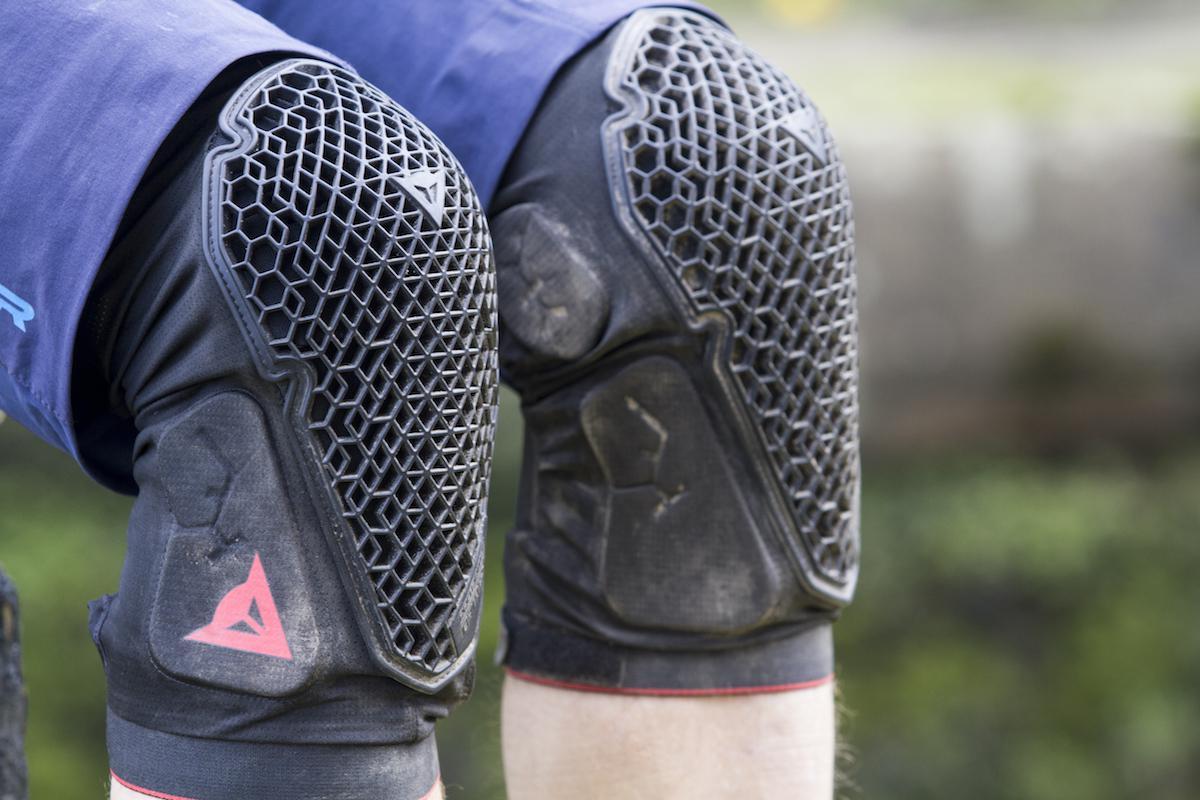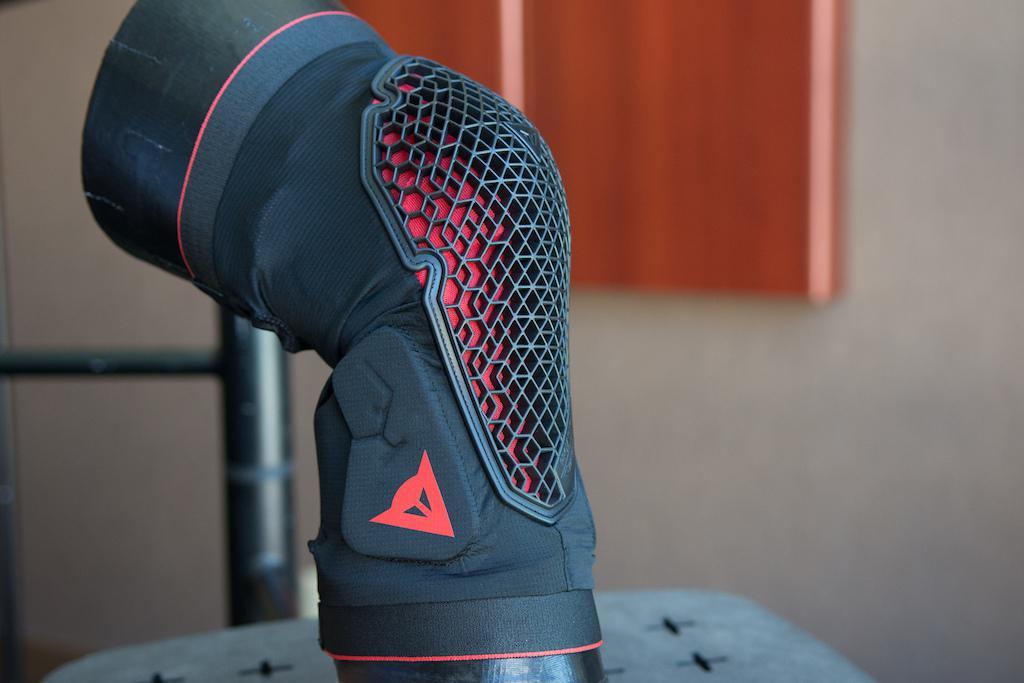The first image is the image on the left, the second image is the image on the right. Analyze the images presented: Is the assertion "In one image, a person is wearing a pair of knee pads with shorts, while the second image is one knee pad displayed on a model leg." valid? Answer yes or no. Yes. The first image is the image on the left, the second image is the image on the right. Examine the images to the left and right. Is the description "A person is wearing two knee braces in the image on the left." accurate? Answer yes or no. Yes. 